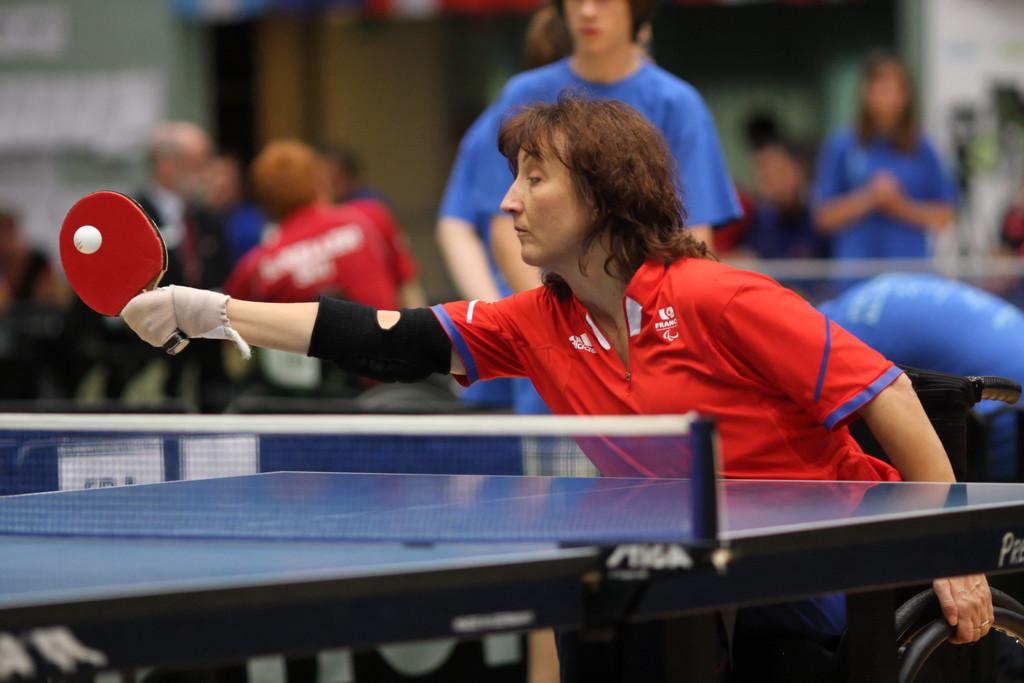What are the people in the image doing? There are people playing table tennis in the image. Are there any other activities being performed by the people in the image? No, the only activity mentioned in the facts is playing table tennis. What type of hammer is being used by the visitor in the image? There is no mention of a hammer or a visitor in the image, so this question cannot be answered. 